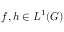Convert formula to latex. <formula><loc_0><loc_0><loc_500><loc_500>f , h \in L ^ { 1 } ( G )</formula> 